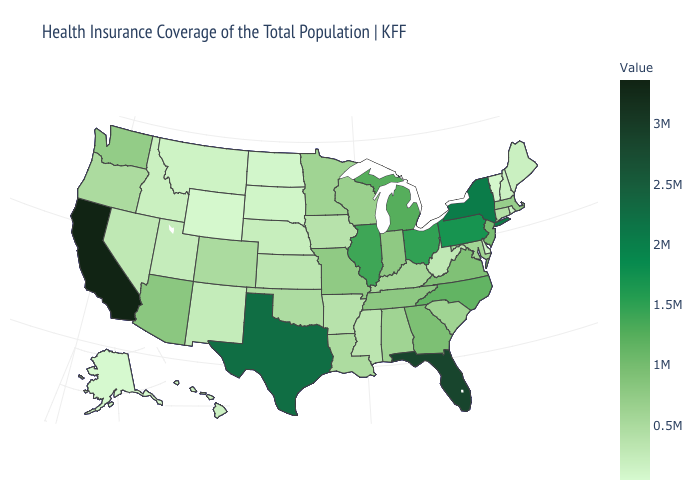Among the states that border Kansas , which have the lowest value?
Keep it brief. Nebraska. Among the states that border Kentucky , does Virginia have the lowest value?
Write a very short answer. No. Does California have the highest value in the West?
Short answer required. Yes. Does Montana have the lowest value in the USA?
Short answer required. No. Which states have the lowest value in the USA?
Give a very brief answer. Alaska. 